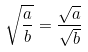<formula> <loc_0><loc_0><loc_500><loc_500>\sqrt { \frac { a } { b } } = \frac { \sqrt { a } } { \sqrt { b } }</formula> 